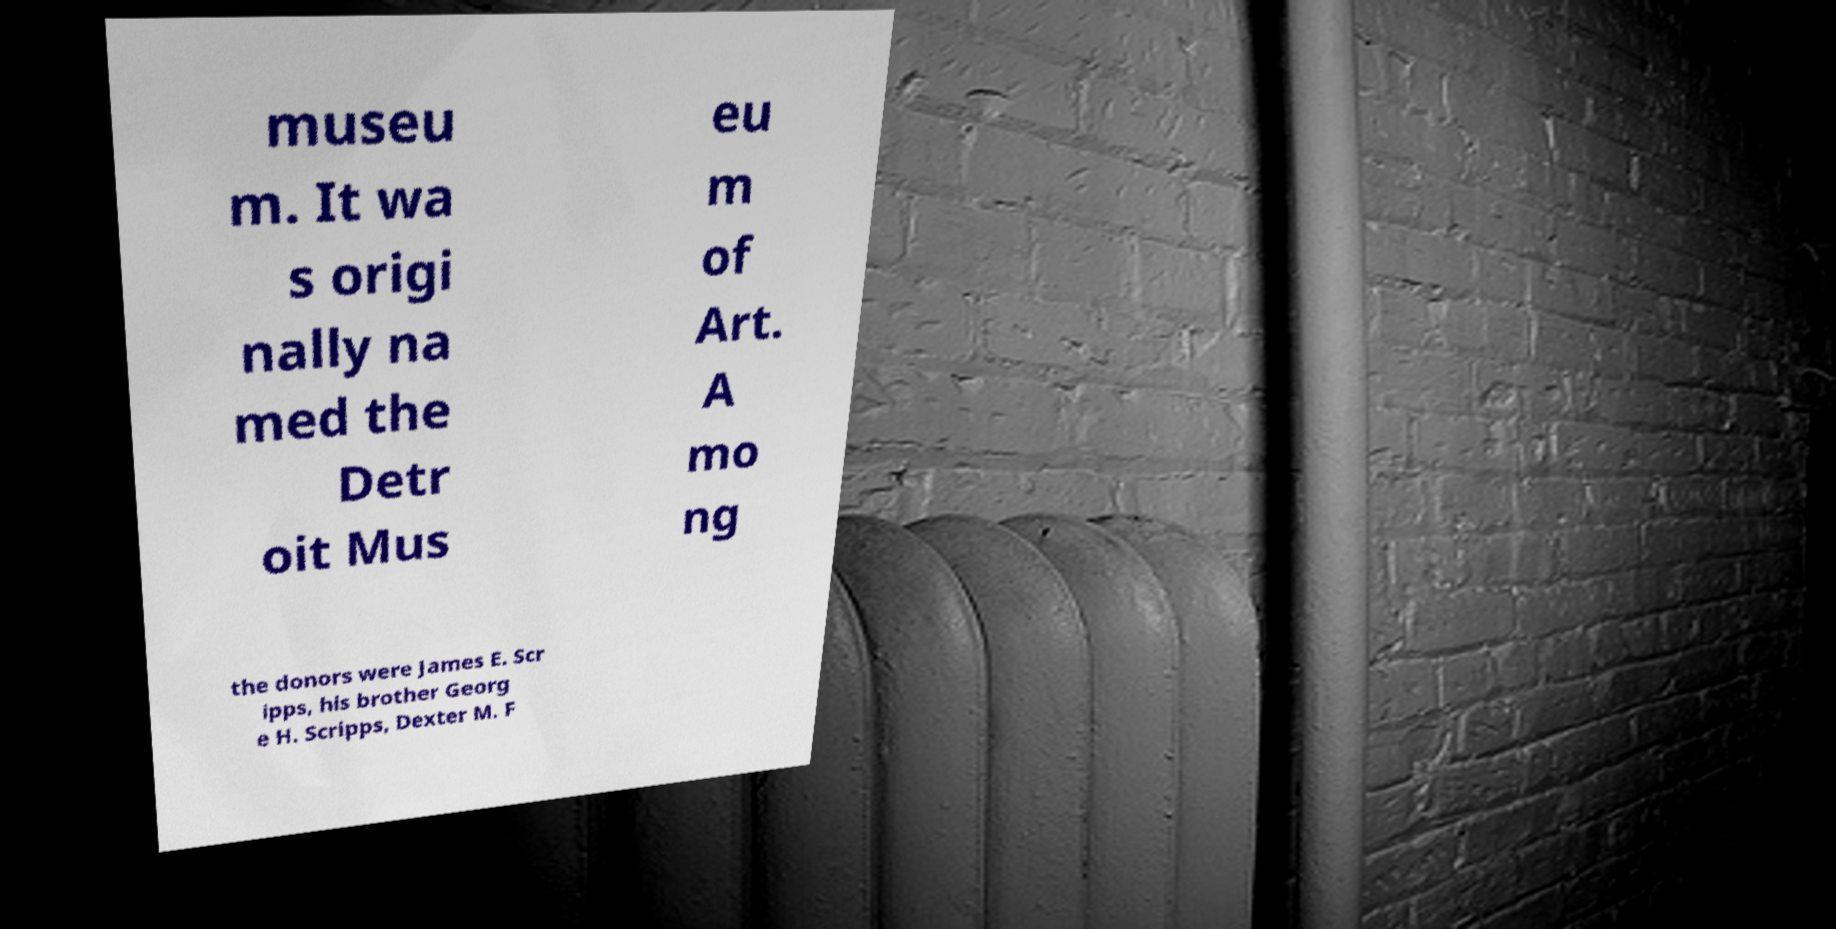I need the written content from this picture converted into text. Can you do that? museu m. It wa s origi nally na med the Detr oit Mus eu m of Art. A mo ng the donors were James E. Scr ipps, his brother Georg e H. Scripps, Dexter M. F 